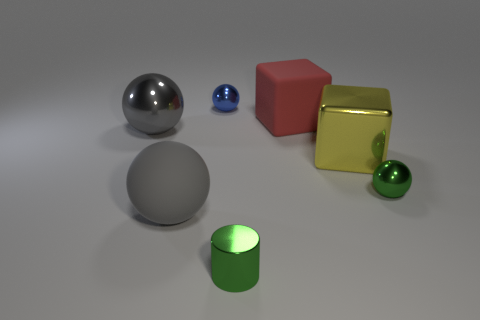Subtract 1 spheres. How many spheres are left? 3 Subtract all cyan cylinders. Subtract all gray balls. How many cylinders are left? 1 Add 1 big yellow shiny objects. How many objects exist? 8 Subtract all blocks. How many objects are left? 5 Subtract all yellow things. Subtract all big gray rubber cylinders. How many objects are left? 6 Add 5 large gray spheres. How many large gray spheres are left? 7 Add 3 big yellow objects. How many big yellow objects exist? 4 Subtract 1 red blocks. How many objects are left? 6 